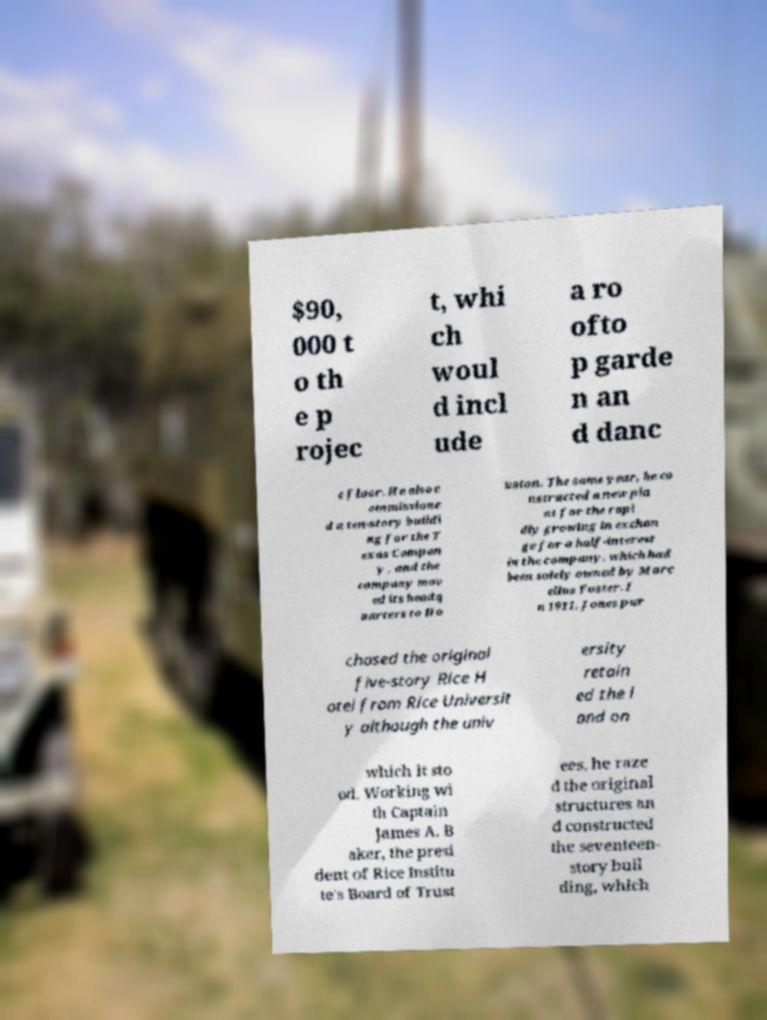Can you accurately transcribe the text from the provided image for me? $90, 000 t o th e p rojec t, whi ch woul d incl ude a ro ofto p garde n an d danc e floor. He also c ommissione d a ten-story buildi ng for the T exas Compan y , and the company mov ed its headq uarters to Ho uston. The same year, he co nstructed a new pla nt for the rapi dly growing in exchan ge for a half-interest in the company, which had been solely owned by Marc ellus Foster. I n 1911, Jones pur chased the original five-story Rice H otel from Rice Universit y although the univ ersity retain ed the l and on which it sto od. Working wi th Captain James A. B aker, the presi dent of Rice Institu te's Board of Trust ees, he raze d the original structures an d constructed the seventeen- story buil ding, which 